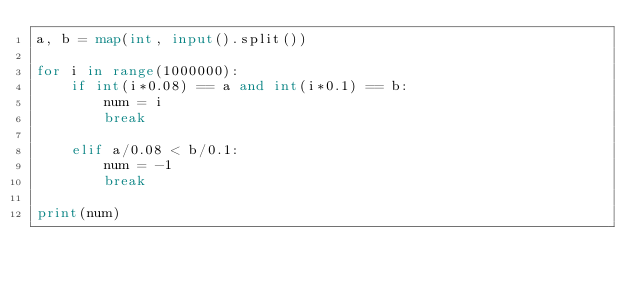Convert code to text. <code><loc_0><loc_0><loc_500><loc_500><_Python_>a, b = map(int, input().split())

for i in range(1000000):
    if int(i*0.08) == a and int(i*0.1) == b:
        num = i
        break

    elif a/0.08 < b/0.1:
        num = -1
        break

print(num)
</code> 